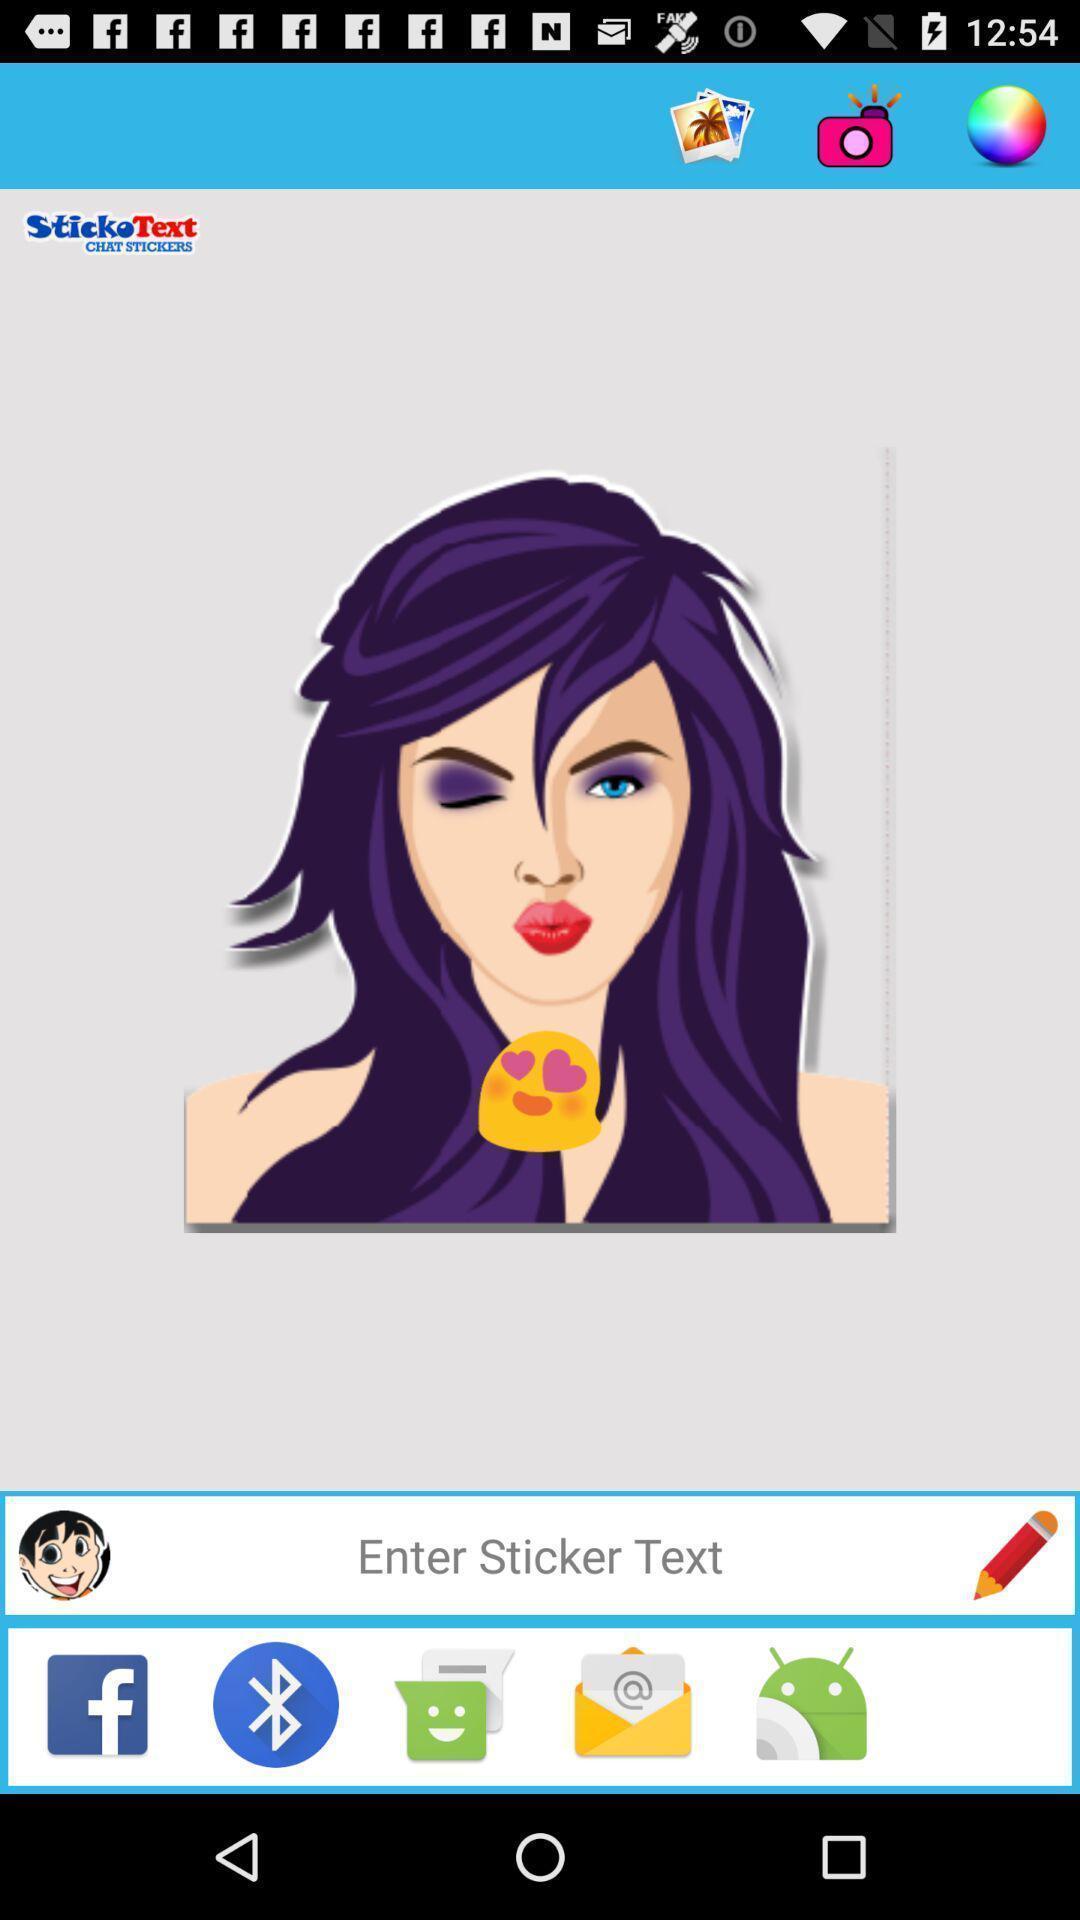Describe this image in words. Sticker app with text tab and other sharing options. 